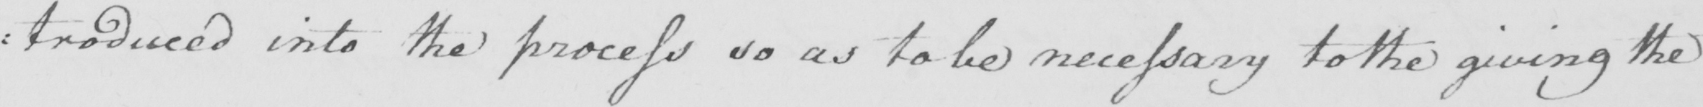Please transcribe the handwritten text in this image. : troduced into the process so as to be necessary to the giving the 